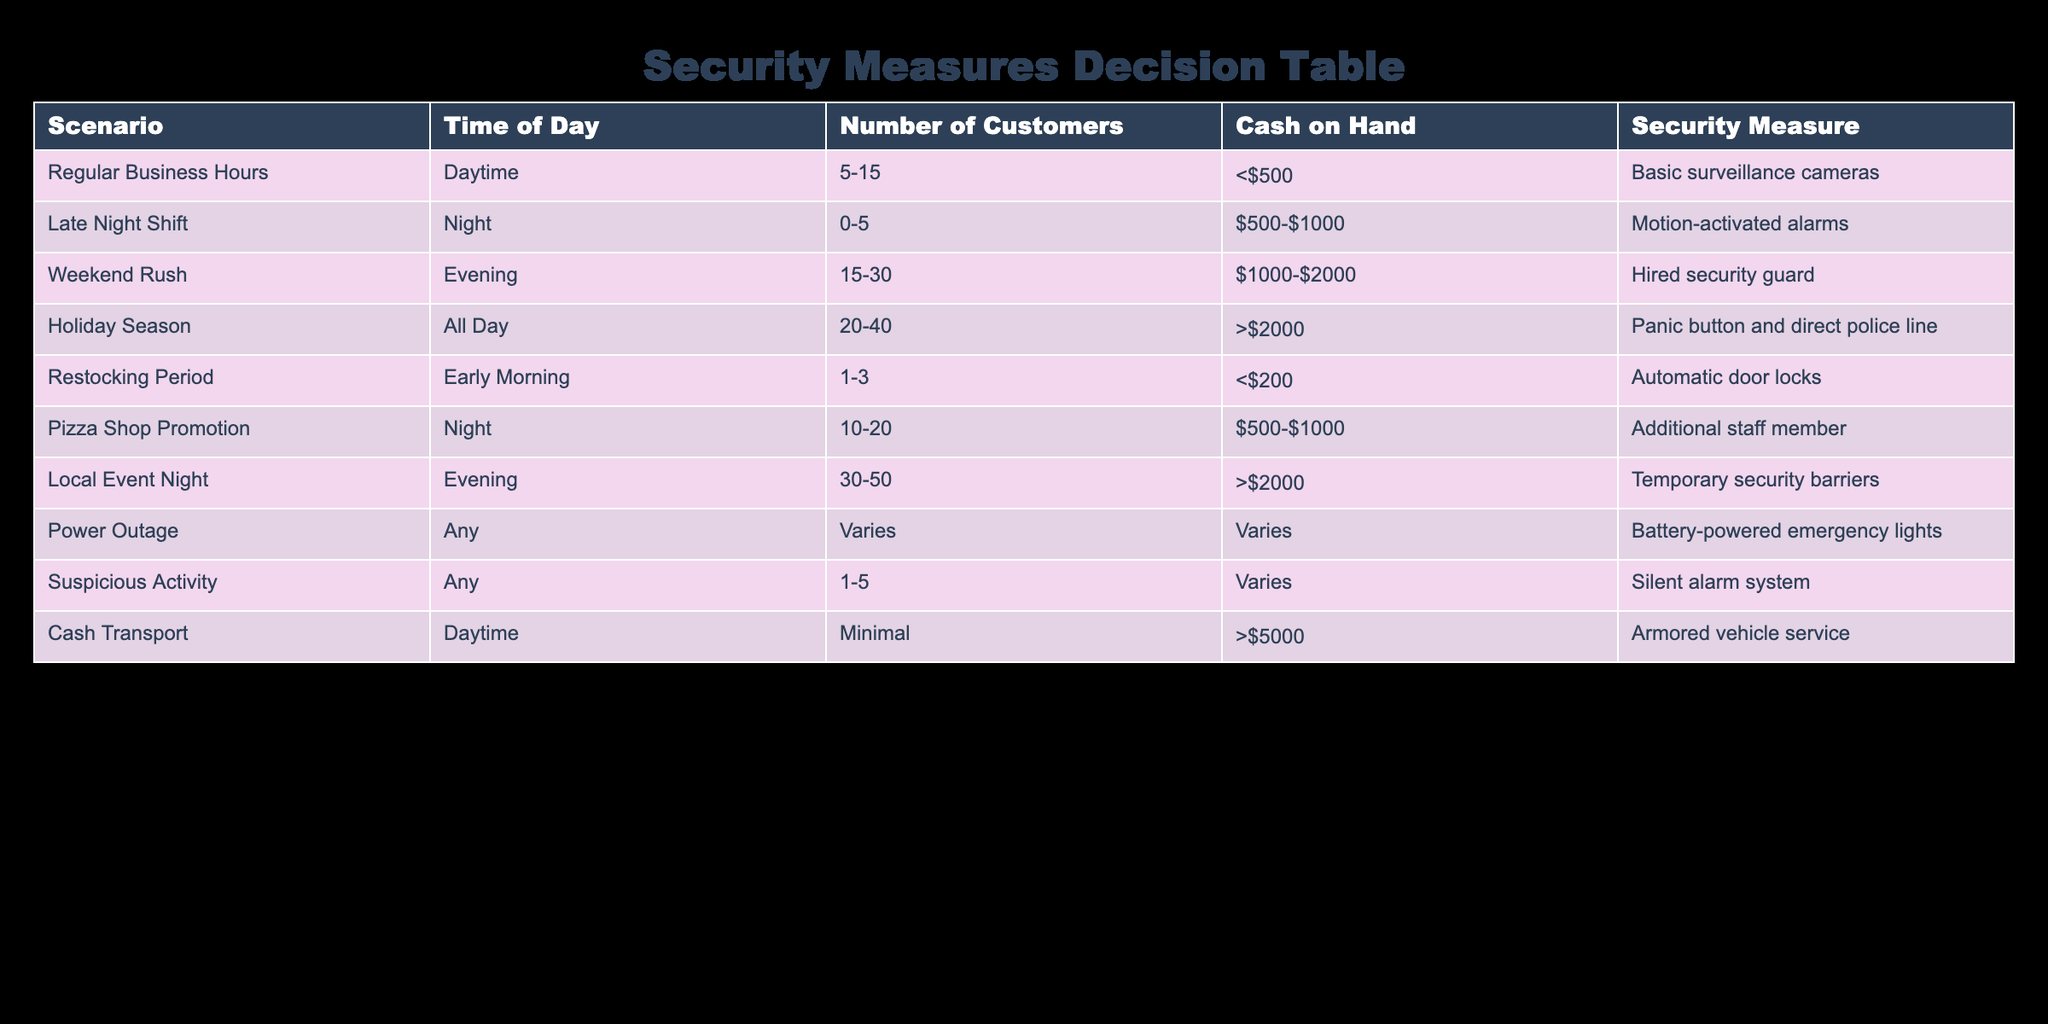What security measure is used during the Holiday Season? The table indicates that during the Holiday Season, the security measure employed is a panic button and direct police line. This information is found by locating the row under the "Holiday Season" scenario.
Answer: Panic button and direct police line How many customers are expected during the Weekend Rush? According to the table, the Weekend Rush scenario has an expected number of customers between 15 to 30. The exact range is specified under the "Number of Customers" column for this scenario.
Answer: 15-30 Are silent alarm systems used for suspicious activity? Yes, the table confirms that for suspicious activity, a silent alarm system is the designated security measure. This is found by checking the row corresponding to "Suspicious Activity."
Answer: Yes What is the security measure when cash transport occurs during the daytime? The table shows that for cash transport during the daytime, the security measure is an armored vehicle service. This information is retrieved from the "Cash Transport" row.
Answer: Armored vehicle service What is the maximum cash on hand during the Late Night Shift scenario? The table states that during the Late Night Shift scenario, the cash on hand is between $500 to $1000. To find this, you look at the "Cash on Hand" column for the "Late Night Shift."
Answer: $500-$1000 How does the number of customers during Local Event Night compare to the Weekend Rush? During Local Event Night, there are 30 to 50 customers, while during Weekend Rush, there are 15 to 30 customers. By comparing the ranges directly from the table, it is clear that Local Event Night has a higher expected customer count.
Answer: Higher What are the different security measures that involve an increased number of customers (20 or more)? The scenarios with an expected number of customers of 20 or more are Holiday Season and Local Event Night. Holiday Season expects 20-40 customers, while Local Event Night expects 30-50 customers. Investigating the "Number of Customers" column for values that meet this criterion leads to these two scenarios.
Answer: Holiday Season, Local Event Night Is the security measure during the Pizza Shop Promotion more or less secure than the one during the Regular Business Hours? The Pizza Shop Promotion has the security measure of an additional staff member, while Regular Business Hours has basic surveillance cameras. Generally, an additional staff member is considered a more proactive security measure compared to cameras alone, indicating it is more secure. This requires comparing the measures from their respective rows.
Answer: More secure What is the average number of customers across all scenarios listed in the table? The customer counts for each scenario are as follows: Regular Business Hours (10), Late Night Shift (2.5), Weekend Rush (22.5), Holiday Season (30), Restocking Period (2), Pizza Shop Promotion (15), Local Event Night (40), and a rough average can be computed by tallying them together. Thus, the average customer count would be: (10 + 2.5 + 22.5 + 30 + 2 + 15 + 40) / 7 = approximately 13.57.
Answer: Approximately 13.57 